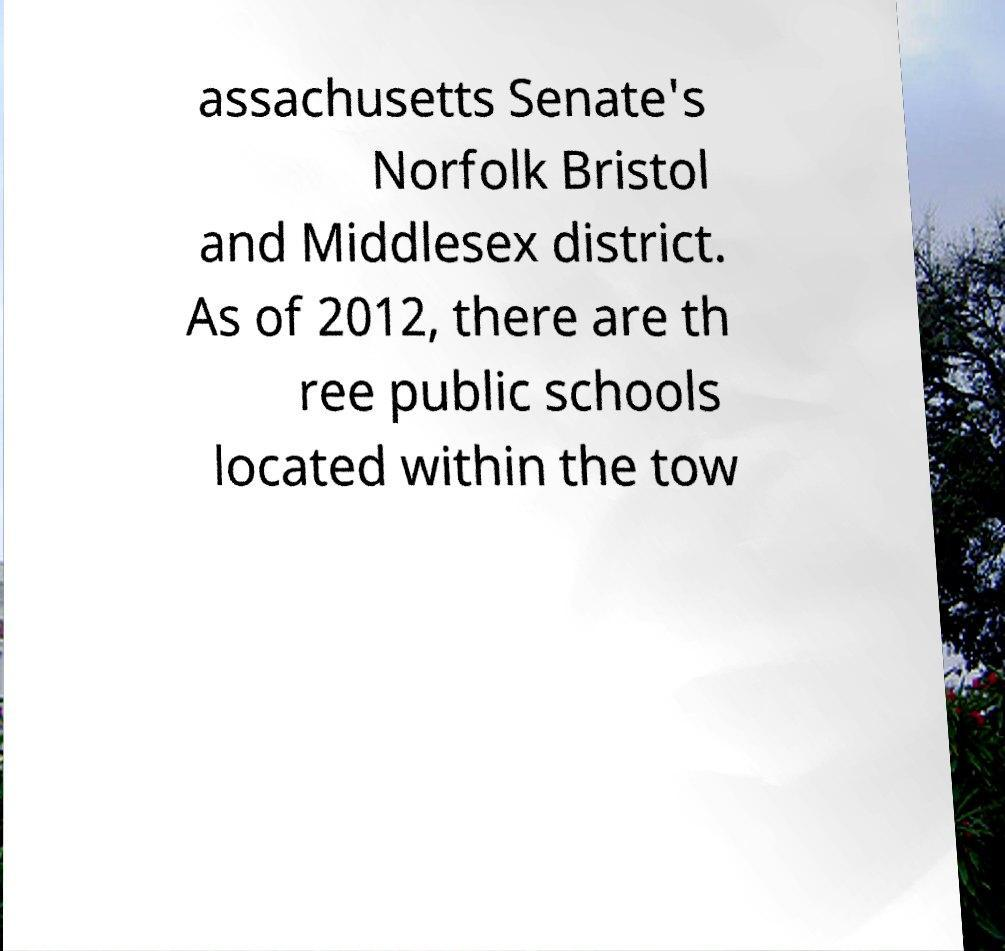Can you read and provide the text displayed in the image?This photo seems to have some interesting text. Can you extract and type it out for me? assachusetts Senate's Norfolk Bristol and Middlesex district. As of 2012, there are th ree public schools located within the tow 